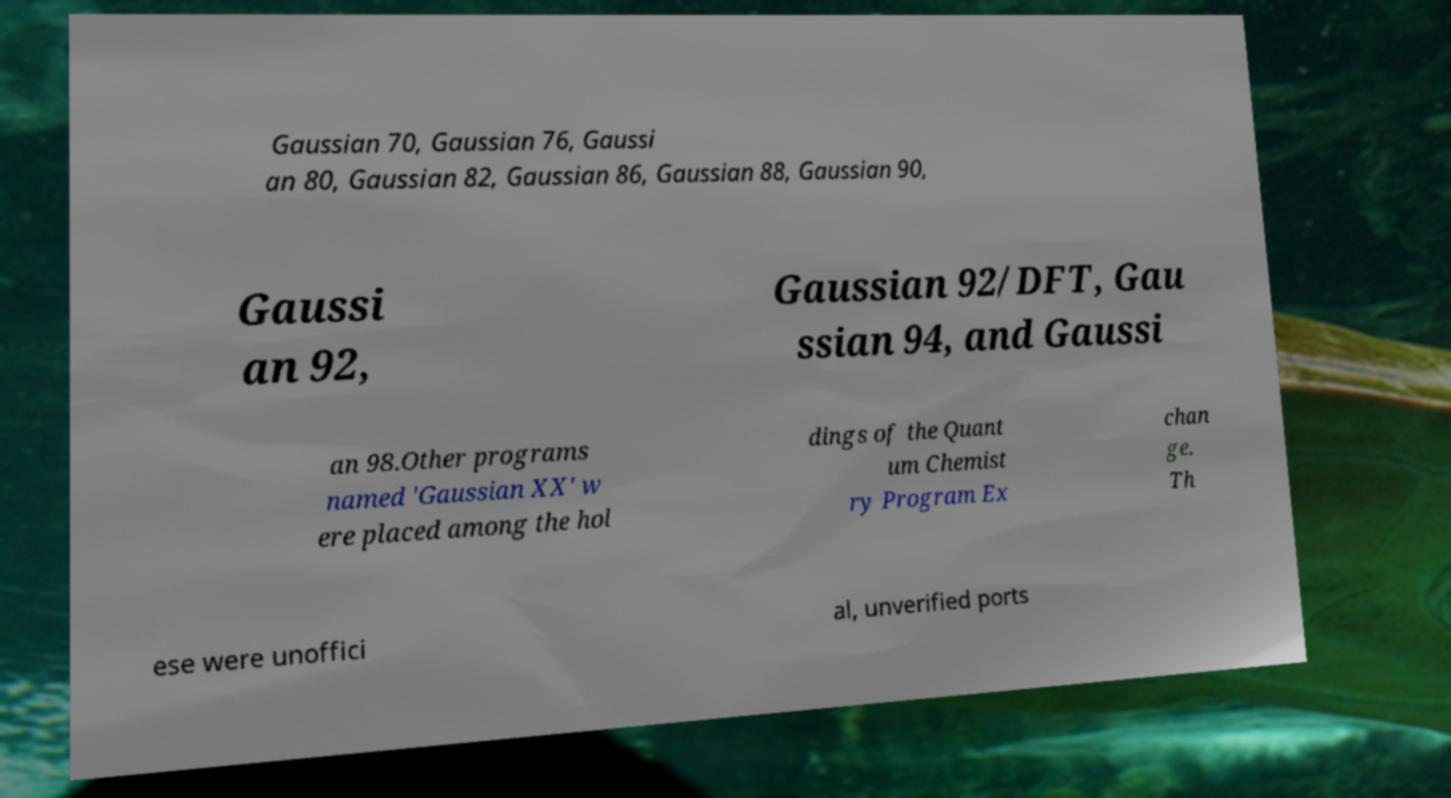There's text embedded in this image that I need extracted. Can you transcribe it verbatim? Gaussian 70, Gaussian 76, Gaussi an 80, Gaussian 82, Gaussian 86, Gaussian 88, Gaussian 90, Gaussi an 92, Gaussian 92/DFT, Gau ssian 94, and Gaussi an 98.Other programs named 'Gaussian XX' w ere placed among the hol dings of the Quant um Chemist ry Program Ex chan ge. Th ese were unoffici al, unverified ports 